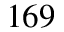<formula> <loc_0><loc_0><loc_500><loc_500>1 6 9</formula> 